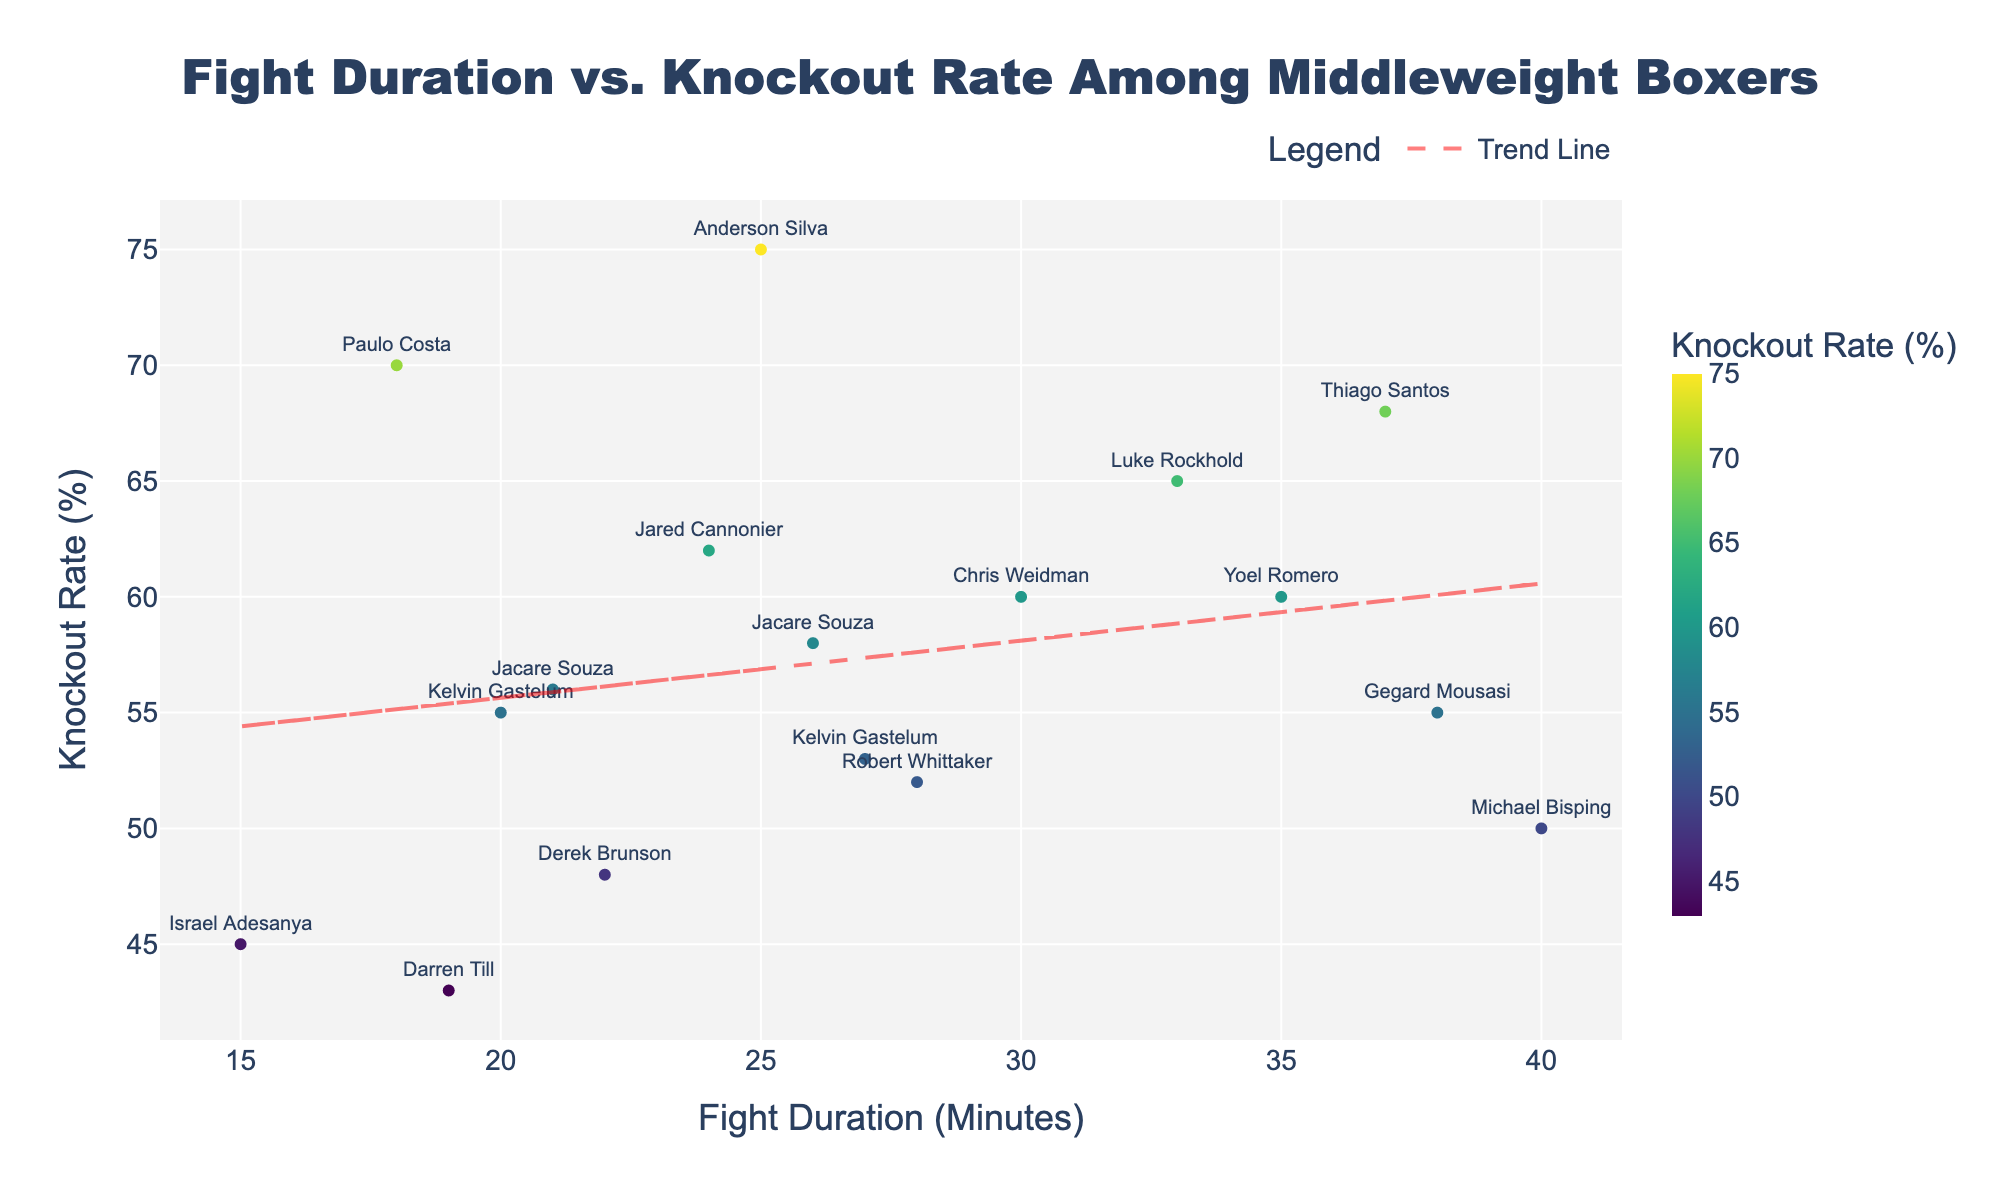What is the title of the plot? The title of the plot is shown at the top center of the figure. By looking at that part, one can identify the title.
Answer: Fight Duration vs. Knockout Rate Among Middleweight Boxers Which boxer has the highest Knockout Rate? To find this, you need to identify the data point that is the highest on the y-axis, which represents the Knockout Rate (%). Checking visually, you find the highest point corresponds to Thiago Santos with a Knockout Rate of 68%.
Answer: Thiago Santos How many boxers have a Knockout Rate above 60%? Look for data points above the 60% mark on the y-axis. Count each data point that meets this criterion. The boxers are Anderson Silva, Luke Rockhold, Paulo Costa, Jared Cannonier, and Thiago Santos, which makes it a total of 5.
Answer: 5 Is there a positive or negative trend between Fight Duration and Knockout Rate? Referring to the trend line added to the scatter plot, observe its slope. If the trend line slopes upwards from left to right, it's positive; if it slopes downwards, it's negative. Here, the trend line slopes upwards, indicating a positive relationship.
Answer: Positive Which boxer with a Fight Duration above 30 minutes has the lowest Knockout Rate? First, filter out the boxers with Fight Durations above 30 minutes by looking along the x-axis. Then, among those points, identify the lowest point on the y-axis, which corresponds to the Knockout Rate. The boxer with the point at the lowest Knockout Rate, considering only those above 30 minutes in Fight Duration, is Michael Bisping with a Knockout Rate of 50%.
Answer: Michael Bisping How does the Knockout Rate of Chris Weidman compare to that of Jared Cannonier? Find the data points for Chris Weidman and Jared Cannonier by their names. Compare their positions along the y-axis (Knockout Rate). Chris Weidman has a Knockout Rate of 60%, and Jared Cannonier has a Knockout Rate of 62%. Therefore, Jared Cannonier has a slightly higher Knockout Rate than Chris Weidman.
Answer: Jared Cannonier has a higher Knockout Rate What is the average Fight Duration of boxers with a Knockout Rate below 55%? Identify the data points with Knockout Rates below 55% (Israel Adesanya, Derek Brunson, Darren Till, Michael Bisping, Robert Whittaker, and Kelvin Gastelum). Sum their Fight Durations and divide by the number of these boxers. (15 + 22 + 19 + 40 + 28 + 27) / 6 = 151 / 6 = 25.17
Answer: 25.17 minutes How do Paulo Costa's Fight Duration and Knockout Rate compare to the average trend? For this, look at Paulo Costa's data point (18 minutes, 70%). Compare these values with the trend line on the scatter plot to see if his data point lies above, below, or on the trend line. Paulo Costa's Knockout Rate (70%) is above the trend prediction for Fight Duration of 18 minutes, indicating he performs better than average in Knockout Rate for his Fight Duration.
Answer: Above trend Which boxer with a Knockout Rate of exactly 60% has the highest Fight Duration? Identify the boxers who have a Knockout Rate of 60% (Chris Weidman and Yoel Romero). Then compare their Fight Durations. Yoel Romero has a Fight Duration of 35 minutes, while Chris Weidman has 30 minutes, so Yoel Romero has the highest Fight Duration among them.
Answer: Yoel Romero 